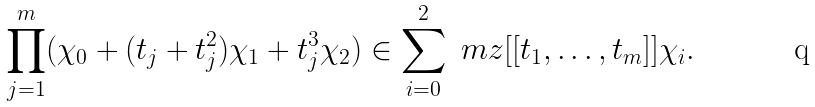<formula> <loc_0><loc_0><loc_500><loc_500>\prod _ { j = 1 } ^ { m } ( \chi _ { 0 } + ( t _ { j } + t _ { j } ^ { 2 } ) \chi _ { 1 } + t _ { j } ^ { 3 } \chi _ { 2 } ) \in \sum _ { i = 0 } ^ { 2 } \ m z [ [ t _ { 1 } , \dots , t _ { m } ] ] \chi _ { i } .</formula> 